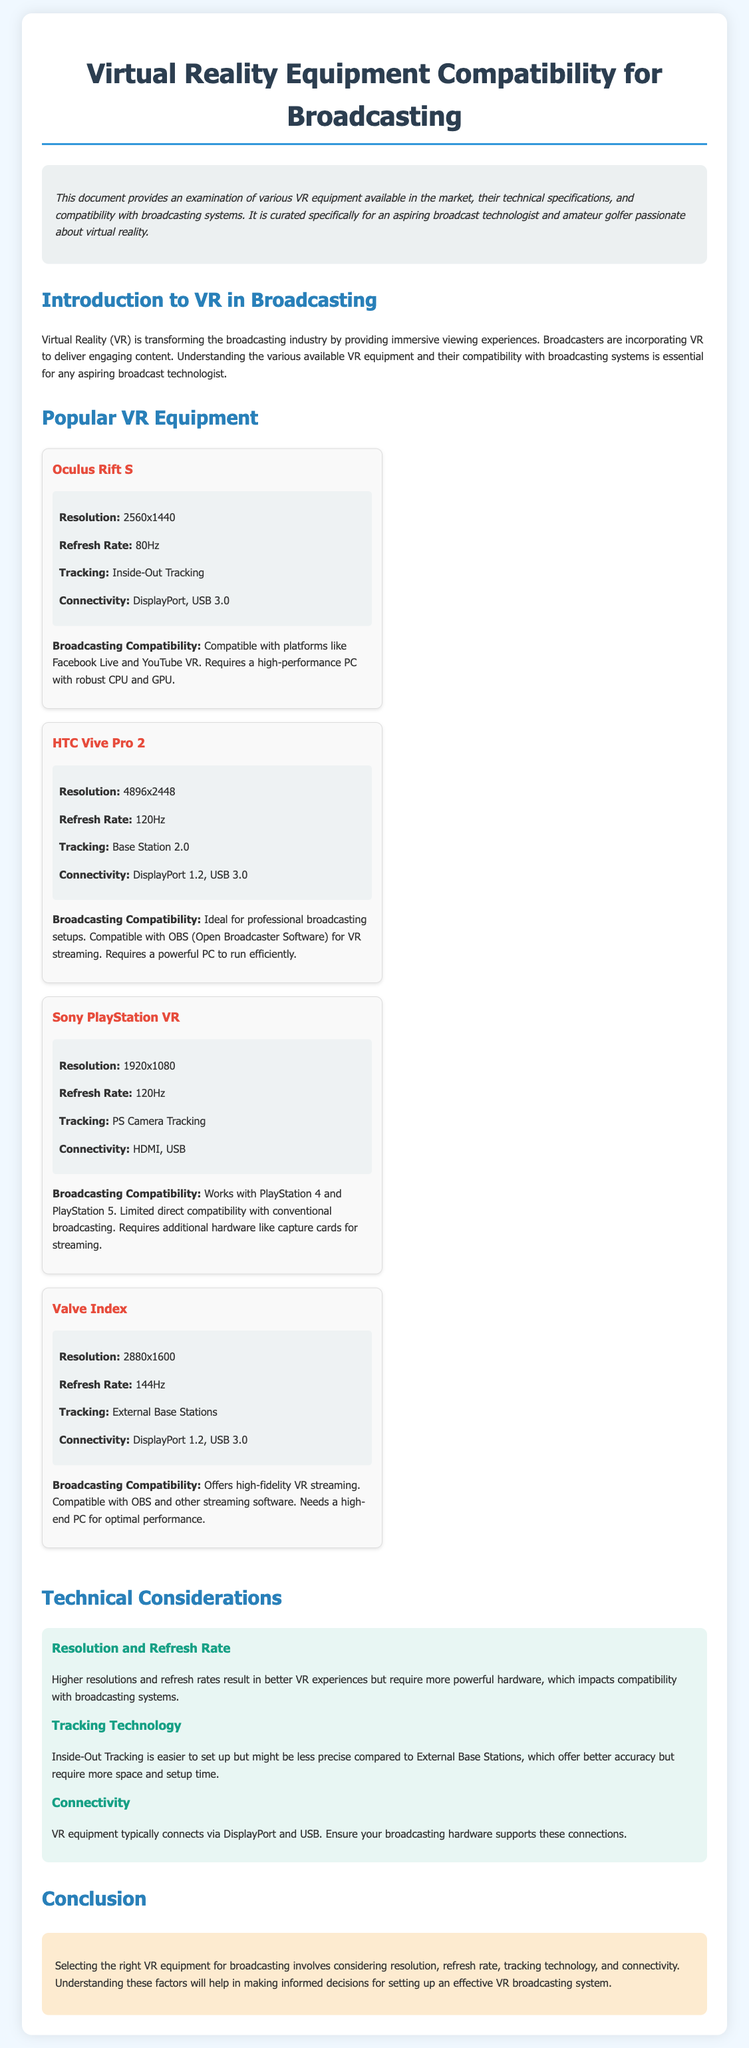What is the resolution of the HTC Vive Pro 2? The resolution is specified directly in the technical specifications section for the HTC Vive Pro 2.
Answer: 4896x2448 What is the refresh rate of the Oculus Rift S? The refresh rate is mentioned in the technical specifications for the Oculus Rift S.
Answer: 80Hz Which VR equipment offers high-fidelity VR streaming? This information is found in the compatibility section for the Valve Index VR equipment.
Answer: Valve Index What tracking technology does the Sony PlayStation VR use? The tracking technology is detailed in the technical specifications section for the Sony PlayStation VR.
Answer: PS Camera Tracking What connection types are commonly used by VR equipment? The document provides a summary of connection types in the technical considerations section.
Answer: DisplayPort and USB Which VR equipment is compatible with OBS for VR streaming? This information is stated in the broadcasting compatibility section of the relevant VR equipment.
Answer: HTC Vive Pro 2, Valve Index How does higher resolution affect broadcasting compatibility? The document explains the relationship between resolution, refresh rate, and broadcasting compatibility in technical considerations.
Answer: Requires more powerful hardware What general advice is given when selecting VR equipment for broadcasting? The conclusion summarizes the essential factors to consider when choosing VR equipment for broadcasting.
Answer: Consider resolution, refresh rate, tracking technology, and connectivity 